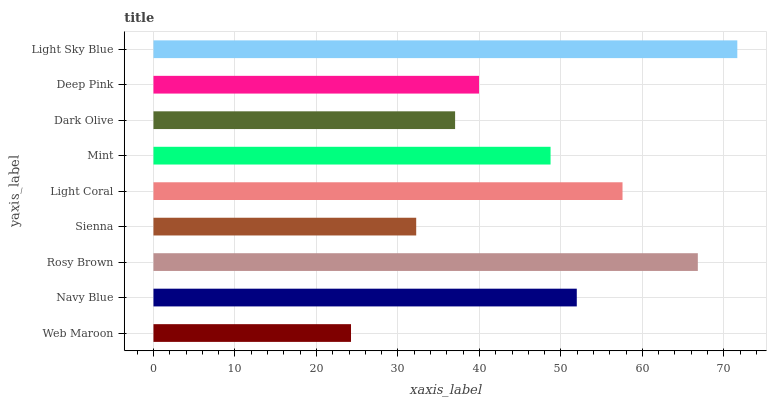Is Web Maroon the minimum?
Answer yes or no. Yes. Is Light Sky Blue the maximum?
Answer yes or no. Yes. Is Navy Blue the minimum?
Answer yes or no. No. Is Navy Blue the maximum?
Answer yes or no. No. Is Navy Blue greater than Web Maroon?
Answer yes or no. Yes. Is Web Maroon less than Navy Blue?
Answer yes or no. Yes. Is Web Maroon greater than Navy Blue?
Answer yes or no. No. Is Navy Blue less than Web Maroon?
Answer yes or no. No. Is Mint the high median?
Answer yes or no. Yes. Is Mint the low median?
Answer yes or no. Yes. Is Web Maroon the high median?
Answer yes or no. No. Is Sienna the low median?
Answer yes or no. No. 